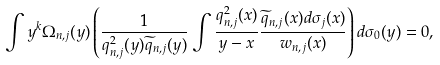<formula> <loc_0><loc_0><loc_500><loc_500>\int y ^ { k } \Omega _ { { n } , j } ( y ) \left ( \frac { 1 } { q _ { { n } , j } ^ { 2 } ( y ) \widetilde { q } _ { { n } , j } ( y ) } \int \frac { q _ { { n } , j } ^ { 2 } ( x ) } { y - x } \frac { \widetilde { q } _ { { n } , j } ( x ) d \sigma _ { j } ( x ) } { w _ { { n } , j } ( x ) } \right ) d \sigma _ { 0 } ( y ) = 0 ,</formula> 